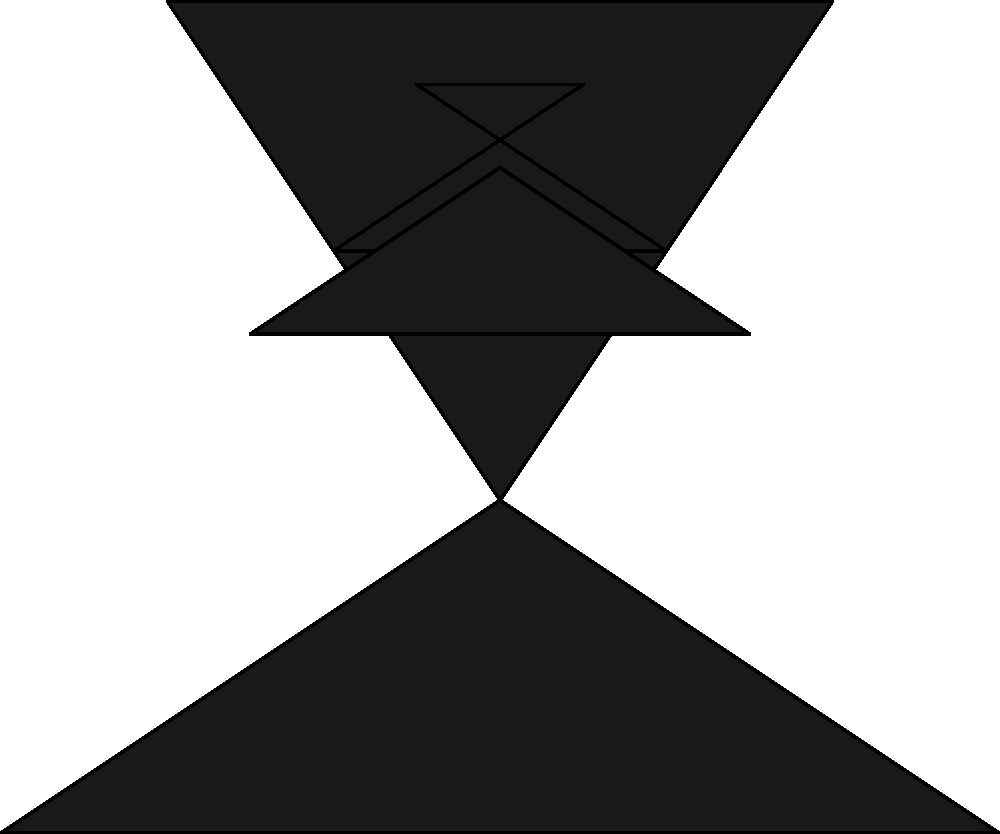As a traditional psychologist, how would you interpret a patient's response if they described seeing "a butterfly emerging from a cocoon" when presented with this Rorschach inkblot image? 1. Analyze the inkblot: The image presents a symmetrical, dark pattern with various shapes and forms.

2. Consider the patient's response: They see "a butterfly emerging from a cocoon."

3. Interpret the symbolism:
   a. Butterfly: Often represents transformation, freedom, and personal growth.
   b. Cocoon: Symbolizes protection, transition, and the potential for change.
   c. Emerging: Indicates a process of revealing oneself or entering a new phase of life.

4. Apply psychological principles:
   a. The response suggests the patient may be experiencing or desiring personal growth and transformation.
   b. It could indicate a readiness to leave a protective environment and embrace new experiences.
   c. The image of emergence may reflect the patient's current life situation or aspirations.

5. Consider the traditional psychoanalytic approach:
   a. Explore the patient's personal associations with butterflies and cocoons.
   b. Investigate any recent life changes or desires for change in the patient's life.
   c. Examine the patient's comfort level with transformation and self-revelation.

6. Emphasize the subjective nature of interpretation:
   a. Recognize that this interpretation is based on traditional psychological theories and personal clinical experience.
   b. Acknowledge that machine learning or AI cannot fully capture the nuances of human perception and symbolism in this context.

7. Plan for further exploration:
   a. Use this response as a starting point for deeper discussion with the patient.
   b. Consider how this interpretation fits with other responses and the overall clinical picture.
Answer: The response suggests the patient may be experiencing or desiring personal growth and transformation, possibly indicating readiness to leave a protective environment and embrace new experiences. 